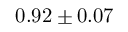<formula> <loc_0><loc_0><loc_500><loc_500>0 . 9 2 \pm 0 . 0 7</formula> 